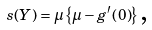Convert formula to latex. <formula><loc_0><loc_0><loc_500><loc_500>s ( Y ) = \mu \left \{ \mu - g ^ { \prime } \left ( 0 \right ) \right \} \text {,}</formula> 